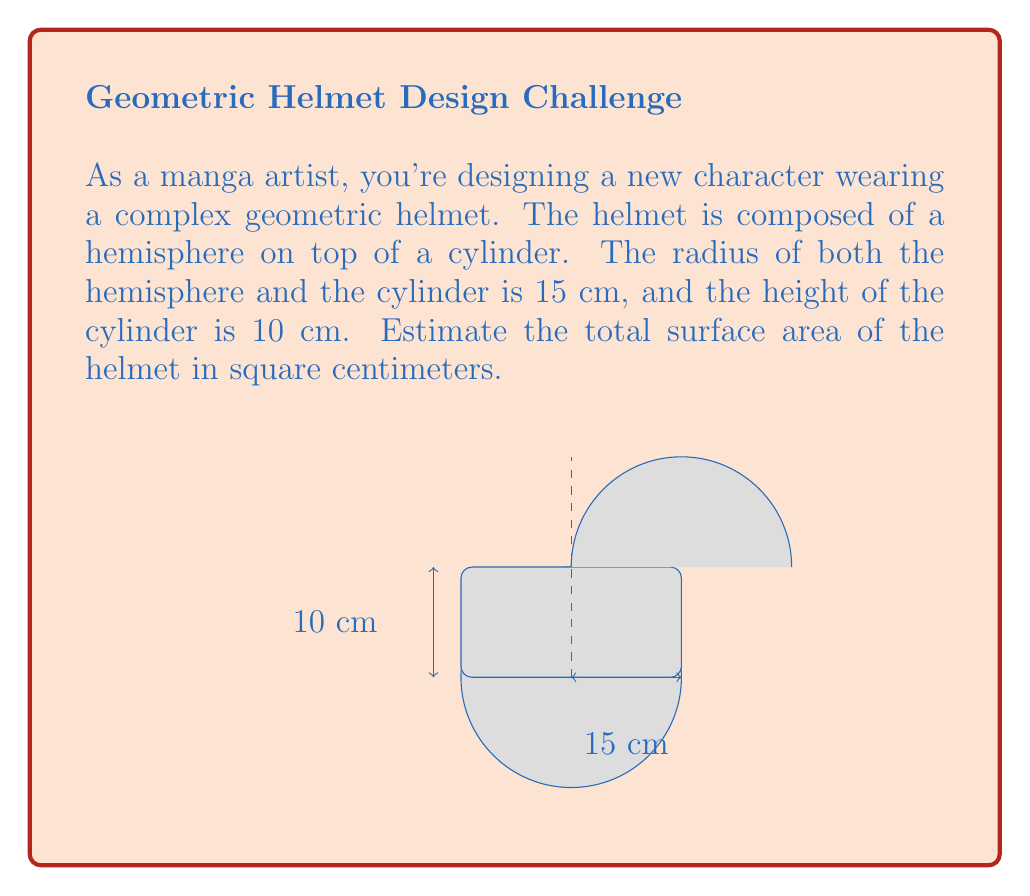Provide a solution to this math problem. Let's break this down step-by-step:

1) The helmet consists of two parts: a hemisphere and a cylinder.

2) For the hemisphere:
   - Surface area of a hemisphere = $2\pi r^2$
   - $r = 15$ cm
   - Area = $2\pi (15)^2 = 450\pi$ cm²

3) For the cylinder:
   - Surface area of a cylinder (excluding top) = $2\pi rh + \pi r^2$
   - $r = 15$ cm, $h = 10$ cm
   - Area = $2\pi (15)(10) + \pi (15)^2$
   - Area = $300\pi + 225\pi = 525\pi$ cm²

4) Total surface area:
   - Total = Hemisphere area + Cylinder area
   - Total = $450\pi + 525\pi = 975\pi$ cm²

5) To get a numerical estimate:
   - $\pi \approx 3.14159$
   - $975\pi \approx 975 * 3.14159 \approx 3063$ cm²

Therefore, the estimated surface area of the helmet is approximately 3063 square centimeters.
Answer: $975\pi$ cm² or approximately 3063 cm² 